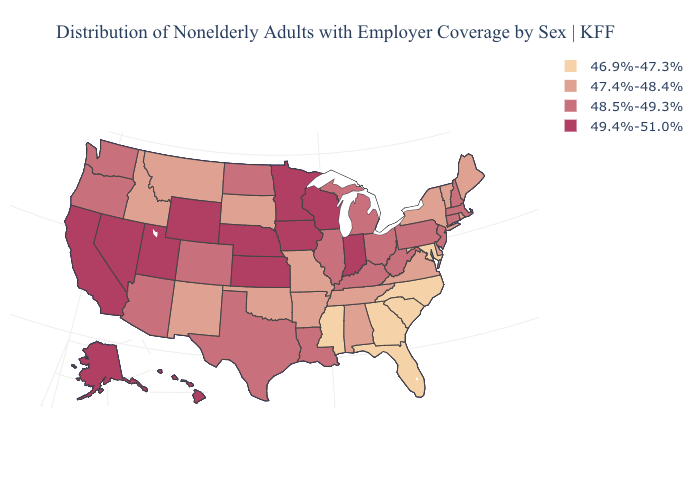Which states have the lowest value in the USA?
Short answer required. Florida, Georgia, Maryland, Mississippi, North Carolina, South Carolina. Which states hav the highest value in the MidWest?
Short answer required. Indiana, Iowa, Kansas, Minnesota, Nebraska, Wisconsin. Name the states that have a value in the range 49.4%-51.0%?
Quick response, please. Alaska, California, Hawaii, Indiana, Iowa, Kansas, Minnesota, Nebraska, Nevada, Utah, Wisconsin, Wyoming. What is the lowest value in the USA?
Concise answer only. 46.9%-47.3%. Name the states that have a value in the range 47.4%-48.4%?
Give a very brief answer. Alabama, Arkansas, Delaware, Idaho, Maine, Missouri, Montana, New Mexico, New York, Oklahoma, Rhode Island, South Dakota, Tennessee, Vermont, Virginia. Does Virginia have the lowest value in the USA?
Give a very brief answer. No. Does Tennessee have the highest value in the USA?
Keep it brief. No. What is the highest value in states that border Florida?
Concise answer only. 47.4%-48.4%. What is the value of Maine?
Give a very brief answer. 47.4%-48.4%. Is the legend a continuous bar?
Short answer required. No. What is the value of Mississippi?
Keep it brief. 46.9%-47.3%. Does the map have missing data?
Give a very brief answer. No. Name the states that have a value in the range 46.9%-47.3%?
Give a very brief answer. Florida, Georgia, Maryland, Mississippi, North Carolina, South Carolina. What is the value of New Hampshire?
Keep it brief. 48.5%-49.3%. Name the states that have a value in the range 46.9%-47.3%?
Concise answer only. Florida, Georgia, Maryland, Mississippi, North Carolina, South Carolina. 